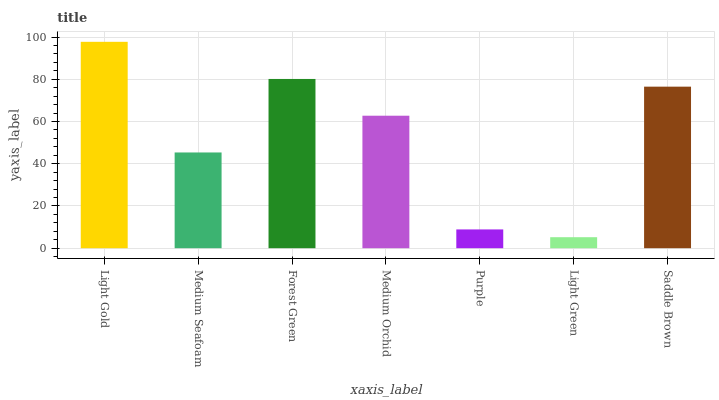Is Light Green the minimum?
Answer yes or no. Yes. Is Light Gold the maximum?
Answer yes or no. Yes. Is Medium Seafoam the minimum?
Answer yes or no. No. Is Medium Seafoam the maximum?
Answer yes or no. No. Is Light Gold greater than Medium Seafoam?
Answer yes or no. Yes. Is Medium Seafoam less than Light Gold?
Answer yes or no. Yes. Is Medium Seafoam greater than Light Gold?
Answer yes or no. No. Is Light Gold less than Medium Seafoam?
Answer yes or no. No. Is Medium Orchid the high median?
Answer yes or no. Yes. Is Medium Orchid the low median?
Answer yes or no. Yes. Is Light Gold the high median?
Answer yes or no. No. Is Forest Green the low median?
Answer yes or no. No. 